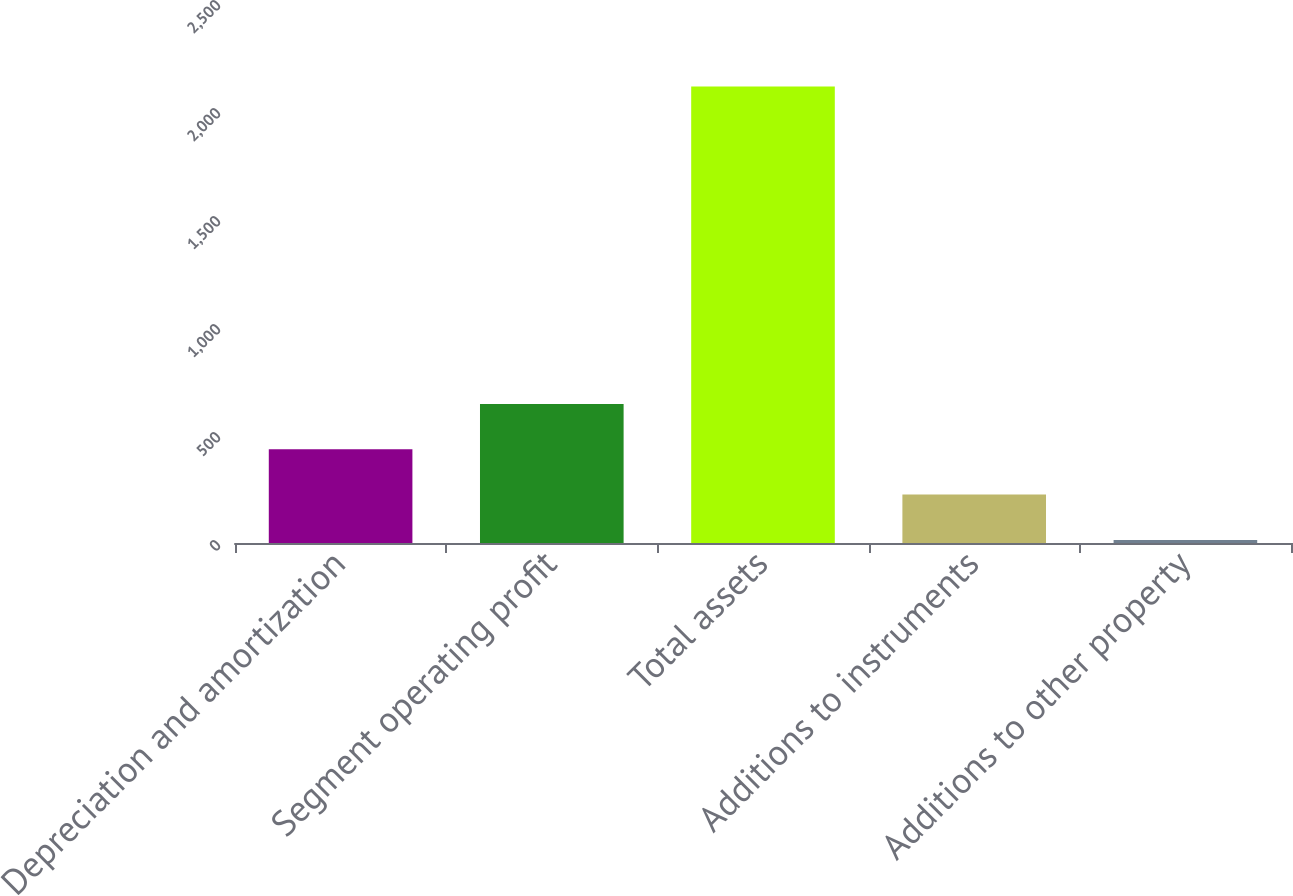Convert chart to OTSL. <chart><loc_0><loc_0><loc_500><loc_500><bar_chart><fcel>Depreciation and amortization<fcel>Segment operating profit<fcel>Total assets<fcel>Additions to instruments<fcel>Additions to other property<nl><fcel>433.9<fcel>643.8<fcel>2113.1<fcel>224<fcel>14.1<nl></chart> 